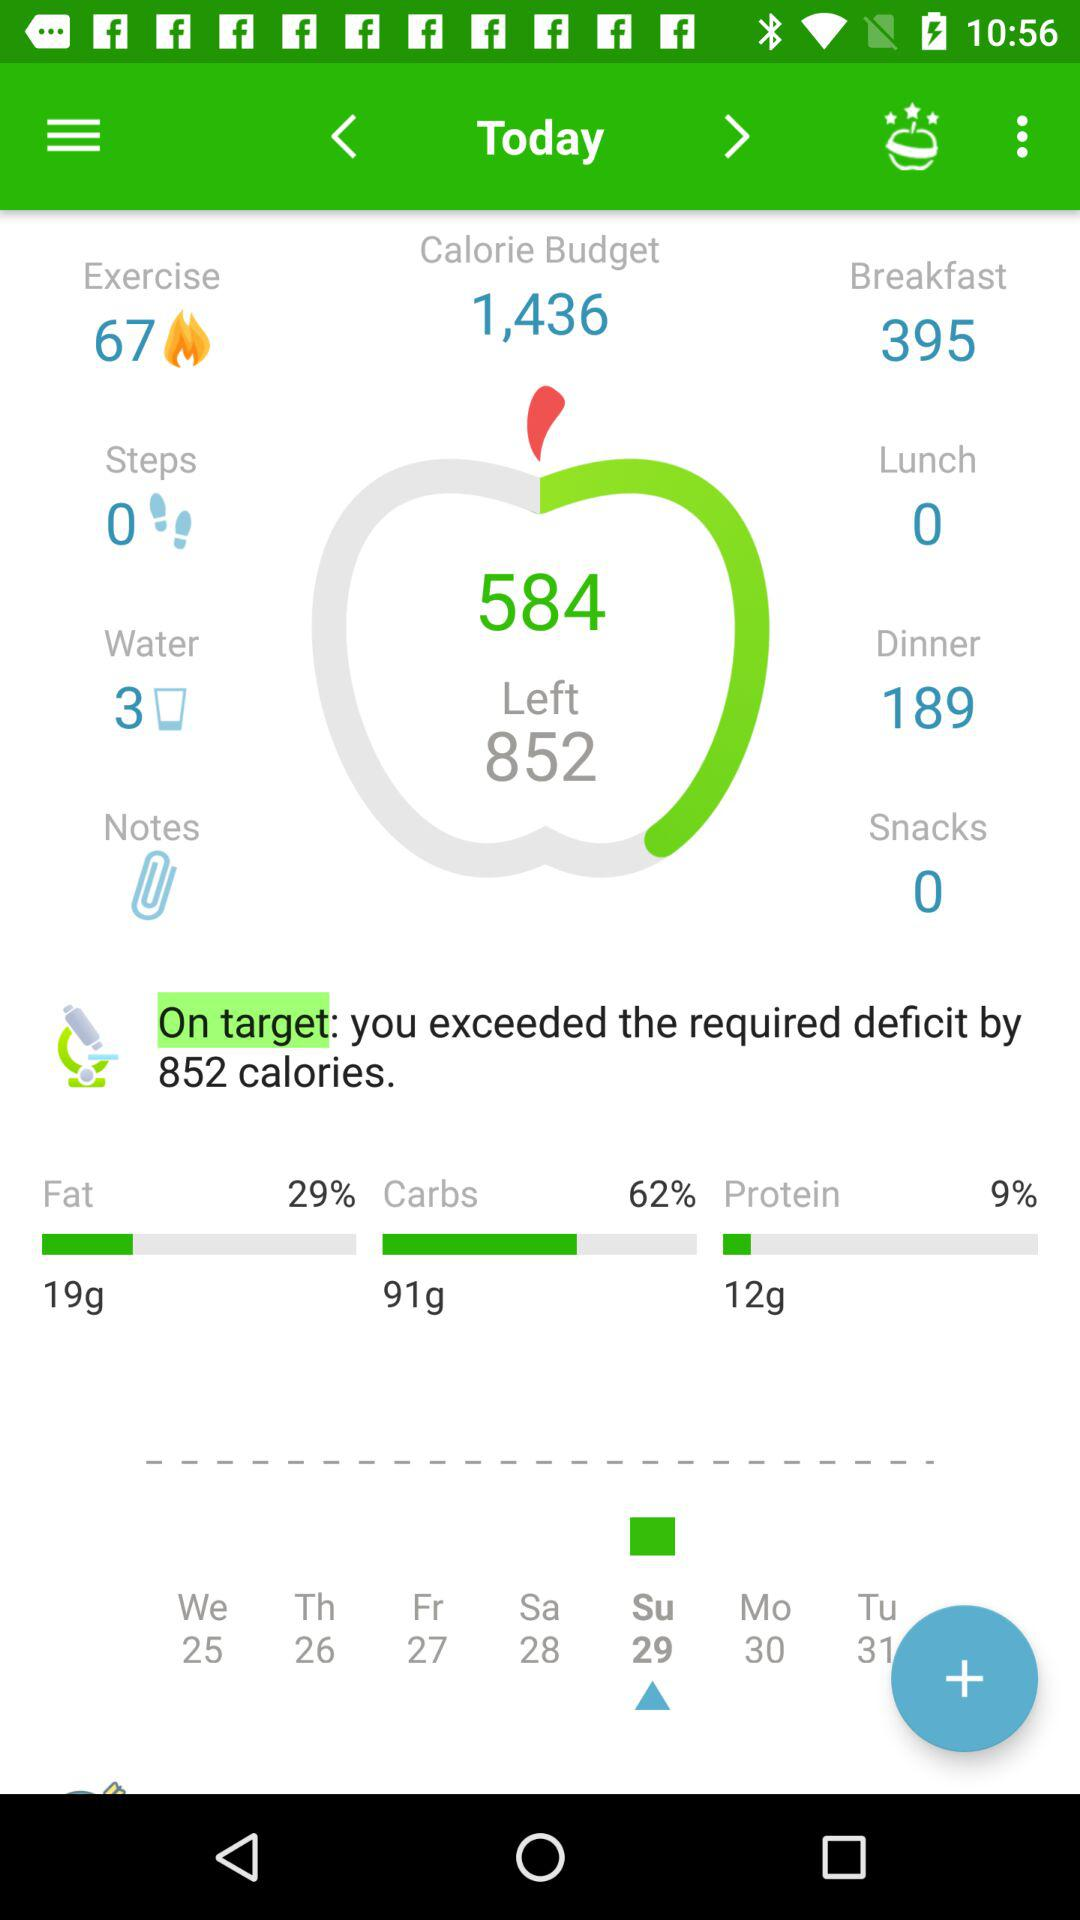What is the number of steps? The number of steps is 0. 